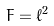Convert formula to latex. <formula><loc_0><loc_0><loc_500><loc_500>F = \ell ^ { 2 }</formula> 